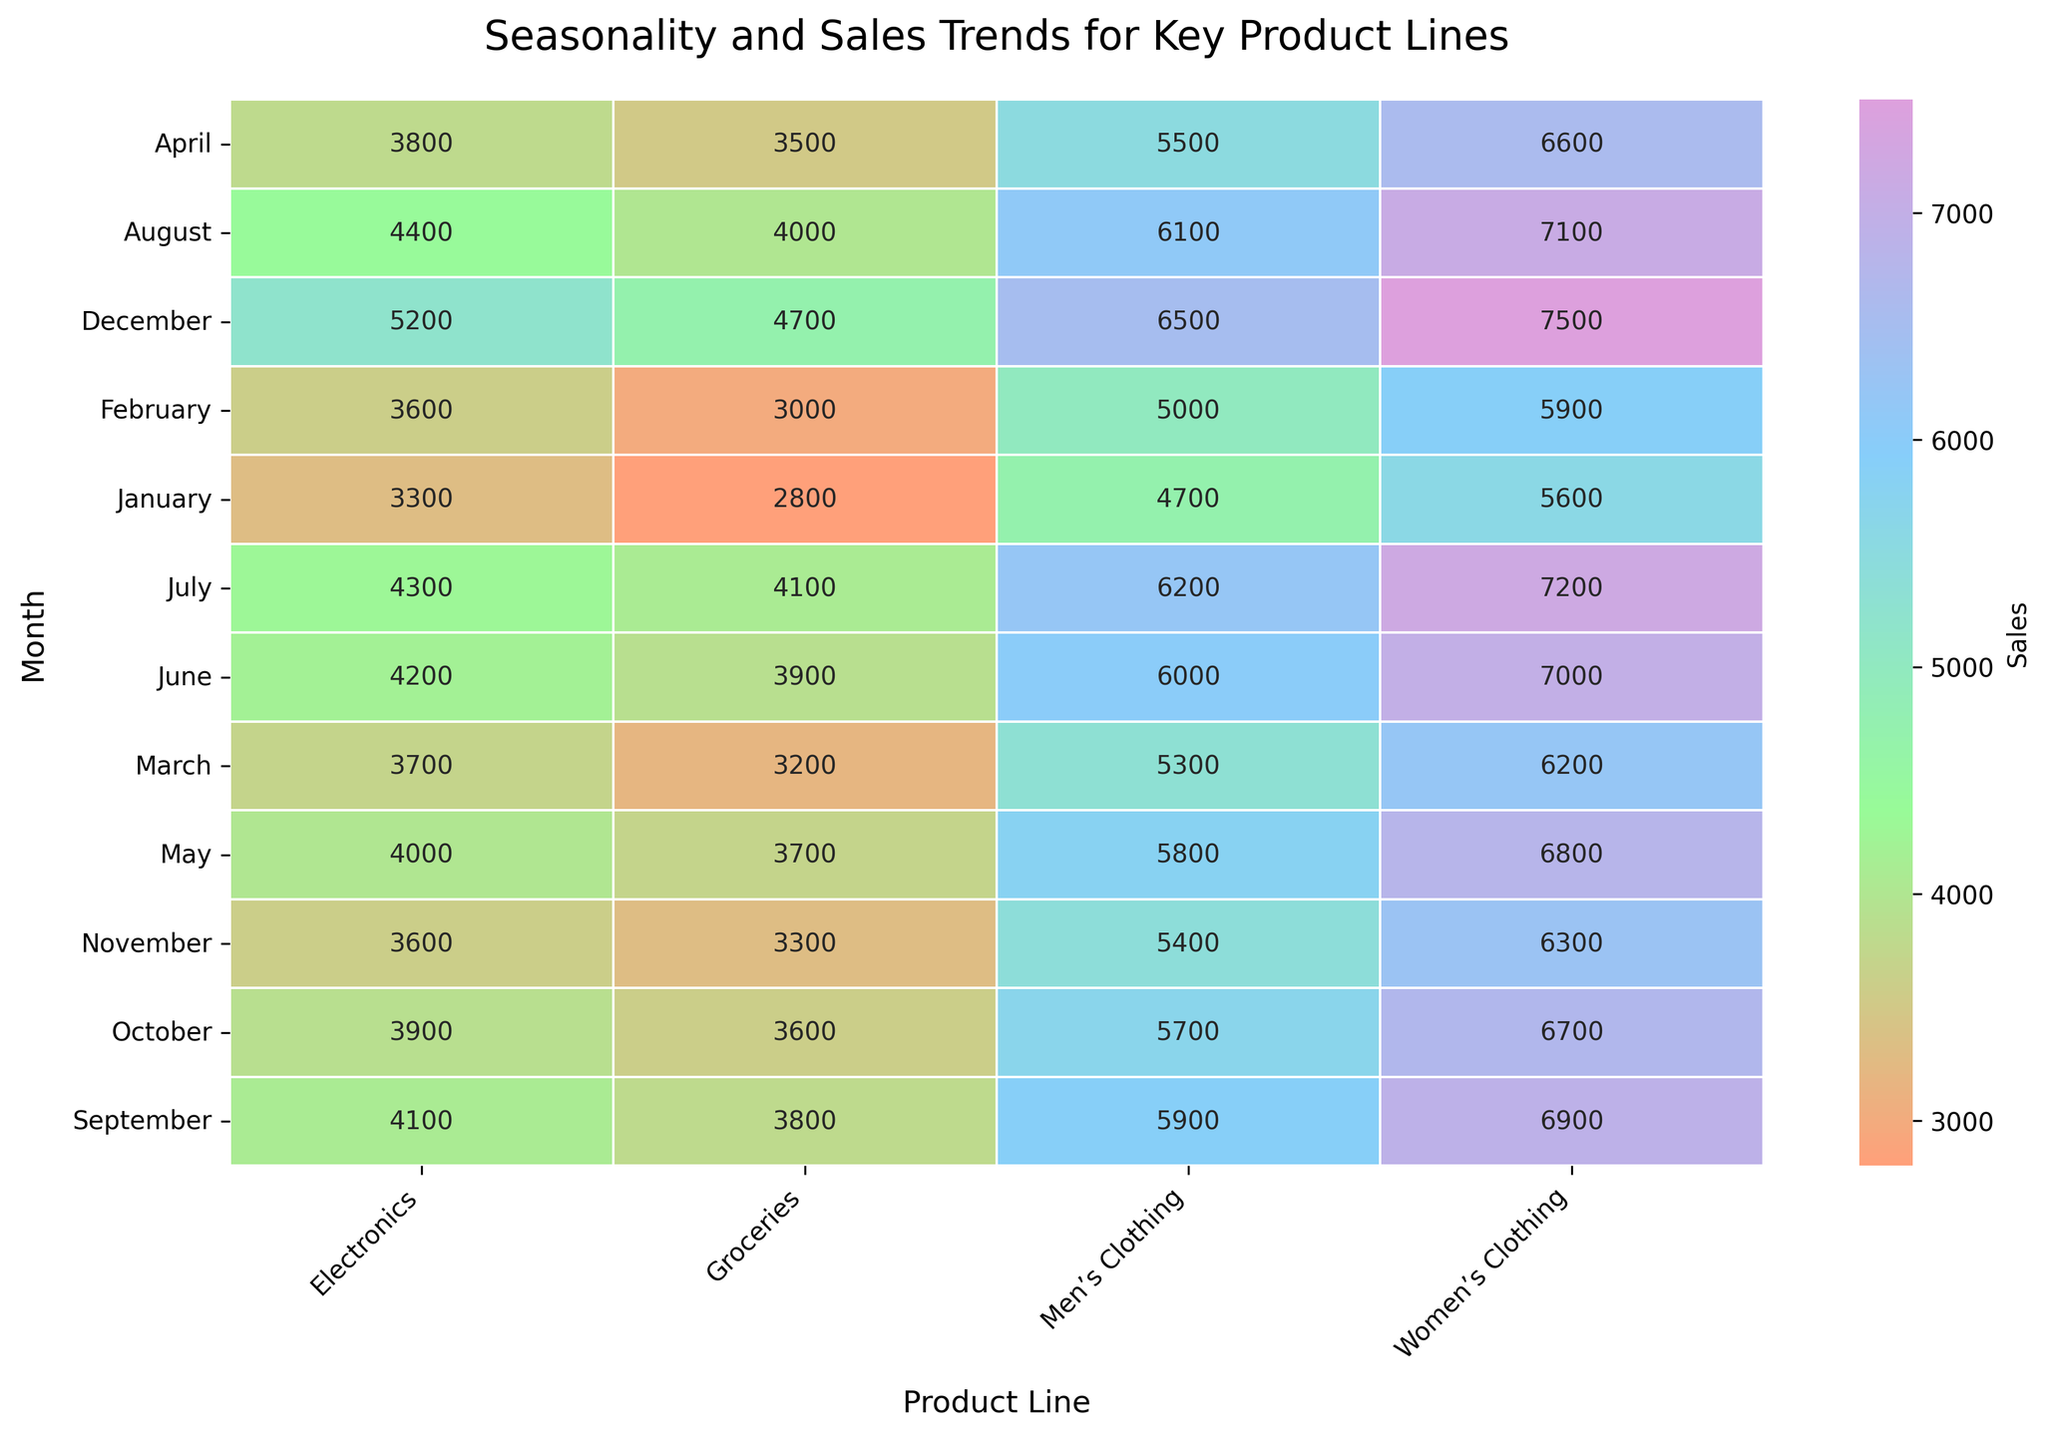What is the title of the heatmap? The title is usually placed at the top of the figure and describes what the plot is about. In this case, the title is "Seasonality and Sales Trends for Key Product Lines".
Answer: Seasonality and Sales Trends for Key Product Lines Which month registered the highest sales for Women’s Clothing? Locate the "Women’s Clothing" column, then identify the cell with the highest value in that column. The data shows the highest sales in December.
Answer: December What were the total sales of Men’s Clothing in the first quarter of the year? The first quarter includes January, February, and March. Sum the sales for Men’s Clothing for these months: 4700 (January) + 5000 (February) + 5300 (March) = 15000.
Answer: 15000 In which month did Electronics see the lowest sales, and what was the value? Locate the "Electronics" column and identify the cell with the lowest value. Here, November has the lowest sales, with a value of 3600.
Answer: November, 3600 Compare the sales of Groceries in July and in December. Which month had higher sales and by how much? Locate the "Groceries" column and find the values for July (4100) and December (4700). Subtract the July sales from the December sales: 4700 - 4100 = 600. December had higher sales by 600.
Answer: December, 600 On the heatmap, which product line shows the most noticeable seasonal pattern across the months and how can you tell? Look at the overall trend and color intensity for each product line. Women’s Clothing shows a noticeable seasonal pattern with significant variations in sales, higher towards the end of the year. This can be identified by the changing intensity of colors in that column.
Answer: Women’s Clothing; significant color changes Between Electronics and Groceries, which product line has a more consistent sales pattern throughout the year? Observe the heatmap columns for "Electronics" and "Groceries". Groceries have a more uniform color distribution, indicating more consistent sales compared to Electronics, whose values vary more.
Answer: Groceries What is the average sales figure for Women’s Clothing over the entire year? Sum the monthly sales for Women’s Clothing: 5600 + 5900 + 6200 + 6600 + 6800 + 7000 + 7200 + 7100 + 6900 + 6700 + 6300 + 7500 = 86800. Divide by 12 (number of months) for the average: 86800/12 ≈ 7233.33.
Answer: 7233.33 Which month had the highest combined sales for all product lines and what was the total? Sum the sales for each product line month by month and identify the highest total. December totals: 7500 (Women’s Clothing) + 6500 (Men’s Clothing) + 5200 (Electronics) + 4700 (Groceries) = 23900.
Answer: December, 23900 